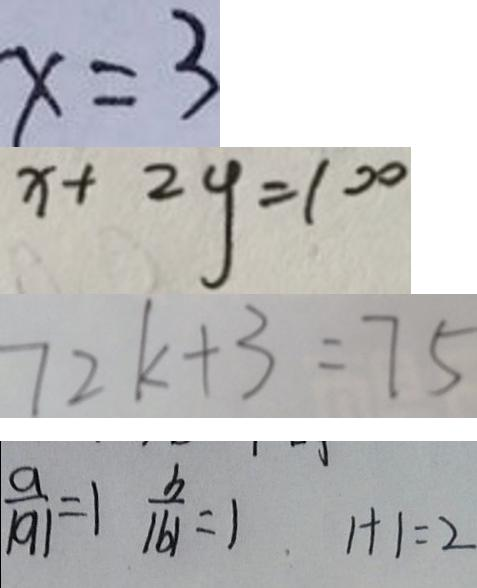<formula> <loc_0><loc_0><loc_500><loc_500>x = 3 
 x + 2 y = 1 0 0 
 7 2 k + 3 = 7 5 
 \frac { a } { \vert a \vert } = 1 \frac { b } { \vert b \vert } = 1 1 + 1 = 2</formula> 